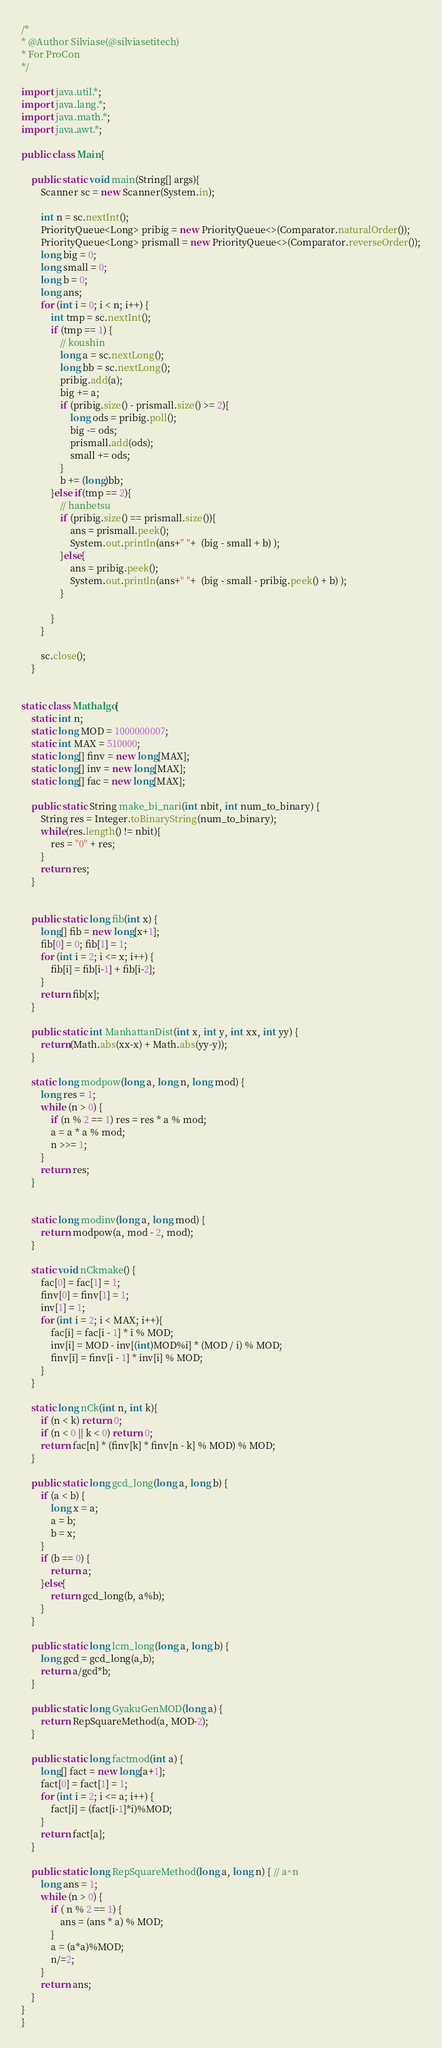<code> <loc_0><loc_0><loc_500><loc_500><_Java_>/*
* @Author Silviase(@silviasetitech)
* For ProCon
*/

import java.util.*;
import java.lang.*;
import java.math.*;
import java.awt.*;

public class Main{

    public static void main(String[] args){
        Scanner sc = new Scanner(System.in);

        int n = sc.nextInt();
        PriorityQueue<Long> pribig = new PriorityQueue<>(Comparator.naturalOrder());
        PriorityQueue<Long> prismall = new PriorityQueue<>(Comparator.reverseOrder());
        long big = 0;
        long small = 0;
        long b = 0;
        long ans;
        for (int i = 0; i < n; i++) {
            int tmp = sc.nextInt();
            if (tmp == 1) {
                // koushin
                long a = sc.nextLong();
                long bb = sc.nextLong();
                pribig.add(a);
                big += a;
                if (pribig.size() - prismall.size() >= 2){
                    long ods = pribig.poll();
                    big -= ods;
                    prismall.add(ods);
                    small += ods;
                }
                b += (long)bb;
            }else if(tmp == 2){
                // hanbetsu
                if (pribig.size() == prismall.size()){
                    ans = prismall.peek();
                    System.out.println(ans+" "+  (big - small + b) );
                }else{
                    ans = pribig.peek();
                    System.out.println(ans+" "+  (big - small - pribig.peek() + b) );
                }
                
            }
        }

        sc.close();
    }

    
static class Mathalgo{
    static int n;
    static long MOD = 1000000007;
    static int MAX = 510000;
    static long[] finv = new long[MAX];
    static long[] inv = new long[MAX];
    static long[] fac = new long[MAX];

    public static String make_bi_nari(int nbit, int num_to_binary) {
        String res = Integer.toBinaryString(num_to_binary);
        while(res.length() != nbit){
            res = "0" + res;
        }
        return res;
    }


    public static long fib(int x) {
        long[] fib = new long[x+1];
        fib[0] = 0; fib[1] = 1;
        for (int i = 2; i <= x; i++) {
            fib[i] = fib[i-1] + fib[i-2];
        }
        return fib[x];
    }

    public static int ManhattanDist(int x, int y, int xx, int yy) {
        return(Math.abs(xx-x) + Math.abs(yy-y));
    }

    static long modpow(long a, long n, long mod) {
        long res = 1;
        while (n > 0) {
            if (n % 2 == 1) res = res * a % mod;
            a = a * a % mod;
            n >>= 1;
        }
        return res;
    }
    
    
    static long modinv(long a, long mod) {
        return modpow(a, mod - 2, mod);
    }

    static void nCkmake() {
        fac[0] = fac[1] = 1;
        finv[0] = finv[1] = 1;
        inv[1] = 1;
        for (int i = 2; i < MAX; i++){
            fac[i] = fac[i - 1] * i % MOD;
            inv[i] = MOD - inv[(int)MOD%i] * (MOD / i) % MOD;
            finv[i] = finv[i - 1] * inv[i] % MOD;
        }
    }
    
    static long nCk(int n, int k){
        if (n < k) return 0;
        if (n < 0 || k < 0) return 0;
        return fac[n] * (finv[k] * finv[n - k] % MOD) % MOD;
    }

    public static long gcd_long(long a, long b) {
        if (a < b) {
            long x = a;
            a = b;
            b = x;
        }
        if (b == 0) {
            return a;
        }else{
            return gcd_long(b, a%b);
        }
    }

    public static long lcm_long(long a, long b) {
        long gcd = gcd_long(a,b);
        return a/gcd*b;
    }

    public static long GyakuGenMOD(long a) {
        return RepSquareMethod(a, MOD-2);
    }
    
    public static long factmod(int a) {
        long[] fact = new long[a+1];
        fact[0] = fact[1] = 1;
        for (int i = 2; i <= a; i++) {
            fact[i] = (fact[i-1]*i)%MOD;
        }
        return fact[a];
    }

    public static long RepSquareMethod(long a, long n) { // a^n
        long ans = 1;
        while (n > 0) {
            if ( n % 2 == 1) {
                ans = (ans * a) % MOD;
            }
            a = (a*a)%MOD;
            n/=2;
        }
        return ans;
    }
}
}


</code> 